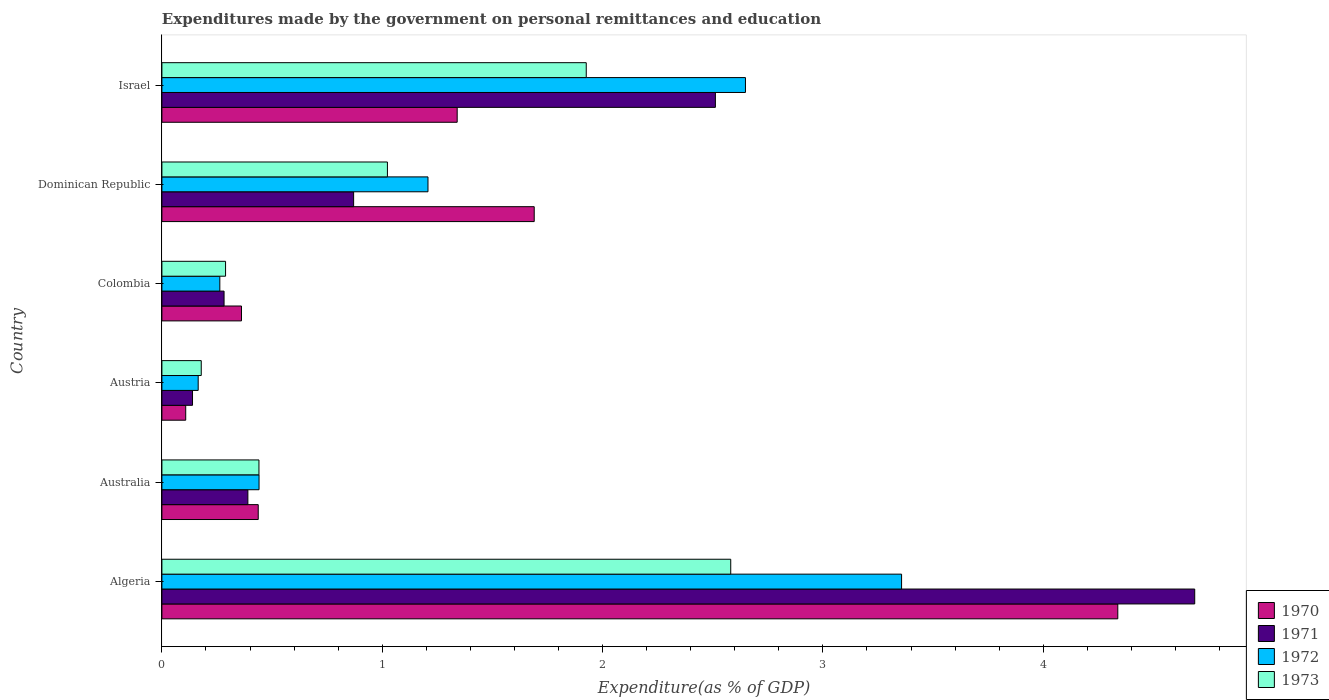How many groups of bars are there?
Offer a very short reply. 6. Are the number of bars per tick equal to the number of legend labels?
Your answer should be compact. Yes. Are the number of bars on each tick of the Y-axis equal?
Provide a succinct answer. Yes. In how many cases, is the number of bars for a given country not equal to the number of legend labels?
Offer a very short reply. 0. What is the expenditures made by the government on personal remittances and education in 1972 in Colombia?
Your answer should be compact. 0.26. Across all countries, what is the maximum expenditures made by the government on personal remittances and education in 1973?
Provide a succinct answer. 2.58. Across all countries, what is the minimum expenditures made by the government on personal remittances and education in 1972?
Provide a succinct answer. 0.16. In which country was the expenditures made by the government on personal remittances and education in 1973 maximum?
Offer a very short reply. Algeria. What is the total expenditures made by the government on personal remittances and education in 1971 in the graph?
Ensure brevity in your answer.  8.88. What is the difference between the expenditures made by the government on personal remittances and education in 1970 in Austria and that in Israel?
Your answer should be very brief. -1.23. What is the difference between the expenditures made by the government on personal remittances and education in 1972 in Australia and the expenditures made by the government on personal remittances and education in 1971 in Algeria?
Offer a very short reply. -4.25. What is the average expenditures made by the government on personal remittances and education in 1971 per country?
Keep it short and to the point. 1.48. What is the difference between the expenditures made by the government on personal remittances and education in 1971 and expenditures made by the government on personal remittances and education in 1970 in Israel?
Your answer should be very brief. 1.17. What is the ratio of the expenditures made by the government on personal remittances and education in 1973 in Algeria to that in Colombia?
Provide a short and direct response. 8.94. Is the difference between the expenditures made by the government on personal remittances and education in 1971 in Algeria and Austria greater than the difference between the expenditures made by the government on personal remittances and education in 1970 in Algeria and Austria?
Your answer should be very brief. Yes. What is the difference between the highest and the second highest expenditures made by the government on personal remittances and education in 1971?
Provide a short and direct response. 2.18. What is the difference between the highest and the lowest expenditures made by the government on personal remittances and education in 1970?
Give a very brief answer. 4.23. In how many countries, is the expenditures made by the government on personal remittances and education in 1972 greater than the average expenditures made by the government on personal remittances and education in 1972 taken over all countries?
Offer a terse response. 2. Is the sum of the expenditures made by the government on personal remittances and education in 1973 in Algeria and Austria greater than the maximum expenditures made by the government on personal remittances and education in 1970 across all countries?
Your response must be concise. No. Is it the case that in every country, the sum of the expenditures made by the government on personal remittances and education in 1972 and expenditures made by the government on personal remittances and education in 1970 is greater than the sum of expenditures made by the government on personal remittances and education in 1971 and expenditures made by the government on personal remittances and education in 1973?
Provide a succinct answer. No. What does the 4th bar from the bottom in Austria represents?
Your answer should be compact. 1973. Is it the case that in every country, the sum of the expenditures made by the government on personal remittances and education in 1971 and expenditures made by the government on personal remittances and education in 1972 is greater than the expenditures made by the government on personal remittances and education in 1973?
Provide a succinct answer. Yes. How many bars are there?
Offer a very short reply. 24. Are all the bars in the graph horizontal?
Ensure brevity in your answer.  Yes. How many countries are there in the graph?
Provide a short and direct response. 6. What is the difference between two consecutive major ticks on the X-axis?
Your answer should be very brief. 1. Does the graph contain any zero values?
Provide a succinct answer. No. Does the graph contain grids?
Give a very brief answer. No. Where does the legend appear in the graph?
Keep it short and to the point. Bottom right. How are the legend labels stacked?
Ensure brevity in your answer.  Vertical. What is the title of the graph?
Ensure brevity in your answer.  Expenditures made by the government on personal remittances and education. Does "1983" appear as one of the legend labels in the graph?
Provide a succinct answer. No. What is the label or title of the X-axis?
Keep it short and to the point. Expenditure(as % of GDP). What is the label or title of the Y-axis?
Your answer should be very brief. Country. What is the Expenditure(as % of GDP) in 1970 in Algeria?
Your response must be concise. 4.34. What is the Expenditure(as % of GDP) in 1971 in Algeria?
Your answer should be very brief. 4.69. What is the Expenditure(as % of GDP) in 1972 in Algeria?
Ensure brevity in your answer.  3.36. What is the Expenditure(as % of GDP) in 1973 in Algeria?
Offer a terse response. 2.58. What is the Expenditure(as % of GDP) in 1970 in Australia?
Provide a short and direct response. 0.44. What is the Expenditure(as % of GDP) in 1971 in Australia?
Keep it short and to the point. 0.39. What is the Expenditure(as % of GDP) of 1972 in Australia?
Your answer should be very brief. 0.44. What is the Expenditure(as % of GDP) of 1973 in Australia?
Provide a succinct answer. 0.44. What is the Expenditure(as % of GDP) of 1970 in Austria?
Give a very brief answer. 0.11. What is the Expenditure(as % of GDP) of 1971 in Austria?
Your answer should be very brief. 0.14. What is the Expenditure(as % of GDP) of 1972 in Austria?
Your response must be concise. 0.16. What is the Expenditure(as % of GDP) in 1973 in Austria?
Your response must be concise. 0.18. What is the Expenditure(as % of GDP) in 1970 in Colombia?
Provide a succinct answer. 0.36. What is the Expenditure(as % of GDP) of 1971 in Colombia?
Keep it short and to the point. 0.28. What is the Expenditure(as % of GDP) in 1972 in Colombia?
Provide a succinct answer. 0.26. What is the Expenditure(as % of GDP) of 1973 in Colombia?
Your answer should be compact. 0.29. What is the Expenditure(as % of GDP) of 1970 in Dominican Republic?
Provide a succinct answer. 1.69. What is the Expenditure(as % of GDP) of 1971 in Dominican Republic?
Your response must be concise. 0.87. What is the Expenditure(as % of GDP) in 1972 in Dominican Republic?
Ensure brevity in your answer.  1.21. What is the Expenditure(as % of GDP) in 1973 in Dominican Republic?
Provide a short and direct response. 1.02. What is the Expenditure(as % of GDP) of 1970 in Israel?
Keep it short and to the point. 1.34. What is the Expenditure(as % of GDP) of 1971 in Israel?
Ensure brevity in your answer.  2.51. What is the Expenditure(as % of GDP) of 1972 in Israel?
Provide a succinct answer. 2.65. What is the Expenditure(as % of GDP) in 1973 in Israel?
Offer a terse response. 1.93. Across all countries, what is the maximum Expenditure(as % of GDP) of 1970?
Give a very brief answer. 4.34. Across all countries, what is the maximum Expenditure(as % of GDP) of 1971?
Your answer should be compact. 4.69. Across all countries, what is the maximum Expenditure(as % of GDP) in 1972?
Provide a short and direct response. 3.36. Across all countries, what is the maximum Expenditure(as % of GDP) of 1973?
Your response must be concise. 2.58. Across all countries, what is the minimum Expenditure(as % of GDP) of 1970?
Your answer should be very brief. 0.11. Across all countries, what is the minimum Expenditure(as % of GDP) of 1971?
Make the answer very short. 0.14. Across all countries, what is the minimum Expenditure(as % of GDP) of 1972?
Give a very brief answer. 0.16. Across all countries, what is the minimum Expenditure(as % of GDP) of 1973?
Offer a terse response. 0.18. What is the total Expenditure(as % of GDP) of 1970 in the graph?
Provide a succinct answer. 8.27. What is the total Expenditure(as % of GDP) in 1971 in the graph?
Provide a succinct answer. 8.88. What is the total Expenditure(as % of GDP) in 1972 in the graph?
Offer a terse response. 8.08. What is the total Expenditure(as % of GDP) of 1973 in the graph?
Provide a short and direct response. 6.44. What is the difference between the Expenditure(as % of GDP) of 1970 in Algeria and that in Australia?
Your answer should be very brief. 3.9. What is the difference between the Expenditure(as % of GDP) in 1971 in Algeria and that in Australia?
Your answer should be compact. 4.3. What is the difference between the Expenditure(as % of GDP) in 1972 in Algeria and that in Australia?
Give a very brief answer. 2.92. What is the difference between the Expenditure(as % of GDP) in 1973 in Algeria and that in Australia?
Offer a very short reply. 2.14. What is the difference between the Expenditure(as % of GDP) of 1970 in Algeria and that in Austria?
Your answer should be very brief. 4.23. What is the difference between the Expenditure(as % of GDP) of 1971 in Algeria and that in Austria?
Ensure brevity in your answer.  4.55. What is the difference between the Expenditure(as % of GDP) of 1972 in Algeria and that in Austria?
Your answer should be compact. 3.19. What is the difference between the Expenditure(as % of GDP) in 1973 in Algeria and that in Austria?
Your response must be concise. 2.4. What is the difference between the Expenditure(as % of GDP) in 1970 in Algeria and that in Colombia?
Give a very brief answer. 3.98. What is the difference between the Expenditure(as % of GDP) in 1971 in Algeria and that in Colombia?
Offer a terse response. 4.41. What is the difference between the Expenditure(as % of GDP) in 1972 in Algeria and that in Colombia?
Make the answer very short. 3.09. What is the difference between the Expenditure(as % of GDP) in 1973 in Algeria and that in Colombia?
Your response must be concise. 2.29. What is the difference between the Expenditure(as % of GDP) of 1970 in Algeria and that in Dominican Republic?
Provide a short and direct response. 2.65. What is the difference between the Expenditure(as % of GDP) of 1971 in Algeria and that in Dominican Republic?
Make the answer very short. 3.82. What is the difference between the Expenditure(as % of GDP) of 1972 in Algeria and that in Dominican Republic?
Make the answer very short. 2.15. What is the difference between the Expenditure(as % of GDP) in 1973 in Algeria and that in Dominican Republic?
Ensure brevity in your answer.  1.56. What is the difference between the Expenditure(as % of GDP) of 1970 in Algeria and that in Israel?
Keep it short and to the point. 3. What is the difference between the Expenditure(as % of GDP) in 1971 in Algeria and that in Israel?
Offer a very short reply. 2.18. What is the difference between the Expenditure(as % of GDP) in 1972 in Algeria and that in Israel?
Your response must be concise. 0.71. What is the difference between the Expenditure(as % of GDP) in 1973 in Algeria and that in Israel?
Offer a terse response. 0.66. What is the difference between the Expenditure(as % of GDP) of 1970 in Australia and that in Austria?
Provide a succinct answer. 0.33. What is the difference between the Expenditure(as % of GDP) in 1971 in Australia and that in Austria?
Provide a succinct answer. 0.25. What is the difference between the Expenditure(as % of GDP) in 1972 in Australia and that in Austria?
Your answer should be compact. 0.28. What is the difference between the Expenditure(as % of GDP) of 1973 in Australia and that in Austria?
Ensure brevity in your answer.  0.26. What is the difference between the Expenditure(as % of GDP) of 1970 in Australia and that in Colombia?
Provide a succinct answer. 0.08. What is the difference between the Expenditure(as % of GDP) in 1971 in Australia and that in Colombia?
Give a very brief answer. 0.11. What is the difference between the Expenditure(as % of GDP) in 1972 in Australia and that in Colombia?
Keep it short and to the point. 0.18. What is the difference between the Expenditure(as % of GDP) in 1973 in Australia and that in Colombia?
Your answer should be compact. 0.15. What is the difference between the Expenditure(as % of GDP) in 1970 in Australia and that in Dominican Republic?
Provide a short and direct response. -1.25. What is the difference between the Expenditure(as % of GDP) in 1971 in Australia and that in Dominican Republic?
Give a very brief answer. -0.48. What is the difference between the Expenditure(as % of GDP) in 1972 in Australia and that in Dominican Republic?
Offer a terse response. -0.77. What is the difference between the Expenditure(as % of GDP) in 1973 in Australia and that in Dominican Republic?
Offer a very short reply. -0.58. What is the difference between the Expenditure(as % of GDP) of 1970 in Australia and that in Israel?
Give a very brief answer. -0.9. What is the difference between the Expenditure(as % of GDP) of 1971 in Australia and that in Israel?
Offer a very short reply. -2.12. What is the difference between the Expenditure(as % of GDP) in 1972 in Australia and that in Israel?
Make the answer very short. -2.21. What is the difference between the Expenditure(as % of GDP) of 1973 in Australia and that in Israel?
Keep it short and to the point. -1.49. What is the difference between the Expenditure(as % of GDP) in 1970 in Austria and that in Colombia?
Provide a short and direct response. -0.25. What is the difference between the Expenditure(as % of GDP) in 1971 in Austria and that in Colombia?
Your response must be concise. -0.14. What is the difference between the Expenditure(as % of GDP) in 1972 in Austria and that in Colombia?
Your response must be concise. -0.1. What is the difference between the Expenditure(as % of GDP) in 1973 in Austria and that in Colombia?
Give a very brief answer. -0.11. What is the difference between the Expenditure(as % of GDP) of 1970 in Austria and that in Dominican Republic?
Give a very brief answer. -1.58. What is the difference between the Expenditure(as % of GDP) of 1971 in Austria and that in Dominican Republic?
Offer a very short reply. -0.73. What is the difference between the Expenditure(as % of GDP) in 1972 in Austria and that in Dominican Republic?
Keep it short and to the point. -1.04. What is the difference between the Expenditure(as % of GDP) of 1973 in Austria and that in Dominican Republic?
Your answer should be compact. -0.84. What is the difference between the Expenditure(as % of GDP) of 1970 in Austria and that in Israel?
Give a very brief answer. -1.23. What is the difference between the Expenditure(as % of GDP) in 1971 in Austria and that in Israel?
Your answer should be very brief. -2.37. What is the difference between the Expenditure(as % of GDP) in 1972 in Austria and that in Israel?
Offer a very short reply. -2.48. What is the difference between the Expenditure(as % of GDP) of 1973 in Austria and that in Israel?
Offer a very short reply. -1.75. What is the difference between the Expenditure(as % of GDP) in 1970 in Colombia and that in Dominican Republic?
Your response must be concise. -1.33. What is the difference between the Expenditure(as % of GDP) of 1971 in Colombia and that in Dominican Republic?
Your answer should be very brief. -0.59. What is the difference between the Expenditure(as % of GDP) in 1972 in Colombia and that in Dominican Republic?
Your answer should be compact. -0.94. What is the difference between the Expenditure(as % of GDP) in 1973 in Colombia and that in Dominican Republic?
Your answer should be very brief. -0.73. What is the difference between the Expenditure(as % of GDP) of 1970 in Colombia and that in Israel?
Keep it short and to the point. -0.98. What is the difference between the Expenditure(as % of GDP) of 1971 in Colombia and that in Israel?
Your answer should be very brief. -2.23. What is the difference between the Expenditure(as % of GDP) of 1972 in Colombia and that in Israel?
Give a very brief answer. -2.39. What is the difference between the Expenditure(as % of GDP) of 1973 in Colombia and that in Israel?
Your response must be concise. -1.64. What is the difference between the Expenditure(as % of GDP) of 1970 in Dominican Republic and that in Israel?
Your response must be concise. 0.35. What is the difference between the Expenditure(as % of GDP) of 1971 in Dominican Republic and that in Israel?
Provide a short and direct response. -1.64. What is the difference between the Expenditure(as % of GDP) of 1972 in Dominican Republic and that in Israel?
Make the answer very short. -1.44. What is the difference between the Expenditure(as % of GDP) in 1973 in Dominican Republic and that in Israel?
Offer a terse response. -0.9. What is the difference between the Expenditure(as % of GDP) of 1970 in Algeria and the Expenditure(as % of GDP) of 1971 in Australia?
Ensure brevity in your answer.  3.95. What is the difference between the Expenditure(as % of GDP) of 1970 in Algeria and the Expenditure(as % of GDP) of 1972 in Australia?
Ensure brevity in your answer.  3.9. What is the difference between the Expenditure(as % of GDP) in 1970 in Algeria and the Expenditure(as % of GDP) in 1973 in Australia?
Your answer should be compact. 3.9. What is the difference between the Expenditure(as % of GDP) in 1971 in Algeria and the Expenditure(as % of GDP) in 1972 in Australia?
Your response must be concise. 4.25. What is the difference between the Expenditure(as % of GDP) in 1971 in Algeria and the Expenditure(as % of GDP) in 1973 in Australia?
Provide a short and direct response. 4.25. What is the difference between the Expenditure(as % of GDP) of 1972 in Algeria and the Expenditure(as % of GDP) of 1973 in Australia?
Give a very brief answer. 2.92. What is the difference between the Expenditure(as % of GDP) in 1970 in Algeria and the Expenditure(as % of GDP) in 1971 in Austria?
Make the answer very short. 4.2. What is the difference between the Expenditure(as % of GDP) of 1970 in Algeria and the Expenditure(as % of GDP) of 1972 in Austria?
Ensure brevity in your answer.  4.17. What is the difference between the Expenditure(as % of GDP) in 1970 in Algeria and the Expenditure(as % of GDP) in 1973 in Austria?
Your answer should be very brief. 4.16. What is the difference between the Expenditure(as % of GDP) in 1971 in Algeria and the Expenditure(as % of GDP) in 1972 in Austria?
Ensure brevity in your answer.  4.52. What is the difference between the Expenditure(as % of GDP) in 1971 in Algeria and the Expenditure(as % of GDP) in 1973 in Austria?
Offer a terse response. 4.51. What is the difference between the Expenditure(as % of GDP) in 1972 in Algeria and the Expenditure(as % of GDP) in 1973 in Austria?
Offer a terse response. 3.18. What is the difference between the Expenditure(as % of GDP) of 1970 in Algeria and the Expenditure(as % of GDP) of 1971 in Colombia?
Your response must be concise. 4.06. What is the difference between the Expenditure(as % of GDP) in 1970 in Algeria and the Expenditure(as % of GDP) in 1972 in Colombia?
Your response must be concise. 4.08. What is the difference between the Expenditure(as % of GDP) of 1970 in Algeria and the Expenditure(as % of GDP) of 1973 in Colombia?
Provide a succinct answer. 4.05. What is the difference between the Expenditure(as % of GDP) of 1971 in Algeria and the Expenditure(as % of GDP) of 1972 in Colombia?
Provide a short and direct response. 4.42. What is the difference between the Expenditure(as % of GDP) in 1971 in Algeria and the Expenditure(as % of GDP) in 1973 in Colombia?
Provide a short and direct response. 4.4. What is the difference between the Expenditure(as % of GDP) in 1972 in Algeria and the Expenditure(as % of GDP) in 1973 in Colombia?
Your response must be concise. 3.07. What is the difference between the Expenditure(as % of GDP) in 1970 in Algeria and the Expenditure(as % of GDP) in 1971 in Dominican Republic?
Provide a succinct answer. 3.47. What is the difference between the Expenditure(as % of GDP) in 1970 in Algeria and the Expenditure(as % of GDP) in 1972 in Dominican Republic?
Provide a short and direct response. 3.13. What is the difference between the Expenditure(as % of GDP) of 1970 in Algeria and the Expenditure(as % of GDP) of 1973 in Dominican Republic?
Provide a short and direct response. 3.31. What is the difference between the Expenditure(as % of GDP) of 1971 in Algeria and the Expenditure(as % of GDP) of 1972 in Dominican Republic?
Provide a short and direct response. 3.48. What is the difference between the Expenditure(as % of GDP) of 1971 in Algeria and the Expenditure(as % of GDP) of 1973 in Dominican Republic?
Offer a very short reply. 3.66. What is the difference between the Expenditure(as % of GDP) of 1972 in Algeria and the Expenditure(as % of GDP) of 1973 in Dominican Republic?
Provide a succinct answer. 2.33. What is the difference between the Expenditure(as % of GDP) of 1970 in Algeria and the Expenditure(as % of GDP) of 1971 in Israel?
Ensure brevity in your answer.  1.83. What is the difference between the Expenditure(as % of GDP) in 1970 in Algeria and the Expenditure(as % of GDP) in 1972 in Israel?
Make the answer very short. 1.69. What is the difference between the Expenditure(as % of GDP) of 1970 in Algeria and the Expenditure(as % of GDP) of 1973 in Israel?
Keep it short and to the point. 2.41. What is the difference between the Expenditure(as % of GDP) of 1971 in Algeria and the Expenditure(as % of GDP) of 1972 in Israel?
Your answer should be compact. 2.04. What is the difference between the Expenditure(as % of GDP) in 1971 in Algeria and the Expenditure(as % of GDP) in 1973 in Israel?
Provide a short and direct response. 2.76. What is the difference between the Expenditure(as % of GDP) of 1972 in Algeria and the Expenditure(as % of GDP) of 1973 in Israel?
Ensure brevity in your answer.  1.43. What is the difference between the Expenditure(as % of GDP) in 1970 in Australia and the Expenditure(as % of GDP) in 1971 in Austria?
Offer a very short reply. 0.3. What is the difference between the Expenditure(as % of GDP) of 1970 in Australia and the Expenditure(as % of GDP) of 1972 in Austria?
Make the answer very short. 0.27. What is the difference between the Expenditure(as % of GDP) of 1970 in Australia and the Expenditure(as % of GDP) of 1973 in Austria?
Offer a terse response. 0.26. What is the difference between the Expenditure(as % of GDP) in 1971 in Australia and the Expenditure(as % of GDP) in 1972 in Austria?
Make the answer very short. 0.23. What is the difference between the Expenditure(as % of GDP) of 1971 in Australia and the Expenditure(as % of GDP) of 1973 in Austria?
Offer a terse response. 0.21. What is the difference between the Expenditure(as % of GDP) in 1972 in Australia and the Expenditure(as % of GDP) in 1973 in Austria?
Provide a succinct answer. 0.26. What is the difference between the Expenditure(as % of GDP) in 1970 in Australia and the Expenditure(as % of GDP) in 1971 in Colombia?
Offer a very short reply. 0.15. What is the difference between the Expenditure(as % of GDP) in 1970 in Australia and the Expenditure(as % of GDP) in 1972 in Colombia?
Offer a very short reply. 0.17. What is the difference between the Expenditure(as % of GDP) in 1970 in Australia and the Expenditure(as % of GDP) in 1973 in Colombia?
Offer a very short reply. 0.15. What is the difference between the Expenditure(as % of GDP) of 1971 in Australia and the Expenditure(as % of GDP) of 1972 in Colombia?
Give a very brief answer. 0.13. What is the difference between the Expenditure(as % of GDP) of 1971 in Australia and the Expenditure(as % of GDP) of 1973 in Colombia?
Ensure brevity in your answer.  0.1. What is the difference between the Expenditure(as % of GDP) of 1972 in Australia and the Expenditure(as % of GDP) of 1973 in Colombia?
Your answer should be very brief. 0.15. What is the difference between the Expenditure(as % of GDP) of 1970 in Australia and the Expenditure(as % of GDP) of 1971 in Dominican Republic?
Provide a succinct answer. -0.43. What is the difference between the Expenditure(as % of GDP) in 1970 in Australia and the Expenditure(as % of GDP) in 1972 in Dominican Republic?
Offer a terse response. -0.77. What is the difference between the Expenditure(as % of GDP) in 1970 in Australia and the Expenditure(as % of GDP) in 1973 in Dominican Republic?
Offer a very short reply. -0.59. What is the difference between the Expenditure(as % of GDP) of 1971 in Australia and the Expenditure(as % of GDP) of 1972 in Dominican Republic?
Your answer should be compact. -0.82. What is the difference between the Expenditure(as % of GDP) in 1971 in Australia and the Expenditure(as % of GDP) in 1973 in Dominican Republic?
Keep it short and to the point. -0.63. What is the difference between the Expenditure(as % of GDP) in 1972 in Australia and the Expenditure(as % of GDP) in 1973 in Dominican Republic?
Ensure brevity in your answer.  -0.58. What is the difference between the Expenditure(as % of GDP) in 1970 in Australia and the Expenditure(as % of GDP) in 1971 in Israel?
Offer a terse response. -2.07. What is the difference between the Expenditure(as % of GDP) of 1970 in Australia and the Expenditure(as % of GDP) of 1972 in Israel?
Give a very brief answer. -2.21. What is the difference between the Expenditure(as % of GDP) in 1970 in Australia and the Expenditure(as % of GDP) in 1973 in Israel?
Give a very brief answer. -1.49. What is the difference between the Expenditure(as % of GDP) of 1971 in Australia and the Expenditure(as % of GDP) of 1972 in Israel?
Keep it short and to the point. -2.26. What is the difference between the Expenditure(as % of GDP) of 1971 in Australia and the Expenditure(as % of GDP) of 1973 in Israel?
Keep it short and to the point. -1.54. What is the difference between the Expenditure(as % of GDP) of 1972 in Australia and the Expenditure(as % of GDP) of 1973 in Israel?
Your answer should be very brief. -1.49. What is the difference between the Expenditure(as % of GDP) of 1970 in Austria and the Expenditure(as % of GDP) of 1971 in Colombia?
Make the answer very short. -0.17. What is the difference between the Expenditure(as % of GDP) of 1970 in Austria and the Expenditure(as % of GDP) of 1972 in Colombia?
Make the answer very short. -0.15. What is the difference between the Expenditure(as % of GDP) of 1970 in Austria and the Expenditure(as % of GDP) of 1973 in Colombia?
Keep it short and to the point. -0.18. What is the difference between the Expenditure(as % of GDP) in 1971 in Austria and the Expenditure(as % of GDP) in 1972 in Colombia?
Offer a very short reply. -0.12. What is the difference between the Expenditure(as % of GDP) of 1971 in Austria and the Expenditure(as % of GDP) of 1973 in Colombia?
Your answer should be very brief. -0.15. What is the difference between the Expenditure(as % of GDP) in 1972 in Austria and the Expenditure(as % of GDP) in 1973 in Colombia?
Give a very brief answer. -0.12. What is the difference between the Expenditure(as % of GDP) in 1970 in Austria and the Expenditure(as % of GDP) in 1971 in Dominican Republic?
Your response must be concise. -0.76. What is the difference between the Expenditure(as % of GDP) of 1970 in Austria and the Expenditure(as % of GDP) of 1972 in Dominican Republic?
Your response must be concise. -1.1. What is the difference between the Expenditure(as % of GDP) of 1970 in Austria and the Expenditure(as % of GDP) of 1973 in Dominican Republic?
Offer a very short reply. -0.92. What is the difference between the Expenditure(as % of GDP) of 1971 in Austria and the Expenditure(as % of GDP) of 1972 in Dominican Republic?
Give a very brief answer. -1.07. What is the difference between the Expenditure(as % of GDP) in 1971 in Austria and the Expenditure(as % of GDP) in 1973 in Dominican Republic?
Offer a very short reply. -0.88. What is the difference between the Expenditure(as % of GDP) in 1972 in Austria and the Expenditure(as % of GDP) in 1973 in Dominican Republic?
Offer a very short reply. -0.86. What is the difference between the Expenditure(as % of GDP) of 1970 in Austria and the Expenditure(as % of GDP) of 1971 in Israel?
Offer a very short reply. -2.4. What is the difference between the Expenditure(as % of GDP) in 1970 in Austria and the Expenditure(as % of GDP) in 1972 in Israel?
Your response must be concise. -2.54. What is the difference between the Expenditure(as % of GDP) of 1970 in Austria and the Expenditure(as % of GDP) of 1973 in Israel?
Keep it short and to the point. -1.82. What is the difference between the Expenditure(as % of GDP) in 1971 in Austria and the Expenditure(as % of GDP) in 1972 in Israel?
Make the answer very short. -2.51. What is the difference between the Expenditure(as % of GDP) of 1971 in Austria and the Expenditure(as % of GDP) of 1973 in Israel?
Provide a succinct answer. -1.79. What is the difference between the Expenditure(as % of GDP) in 1972 in Austria and the Expenditure(as % of GDP) in 1973 in Israel?
Provide a succinct answer. -1.76. What is the difference between the Expenditure(as % of GDP) of 1970 in Colombia and the Expenditure(as % of GDP) of 1971 in Dominican Republic?
Ensure brevity in your answer.  -0.51. What is the difference between the Expenditure(as % of GDP) in 1970 in Colombia and the Expenditure(as % of GDP) in 1972 in Dominican Republic?
Make the answer very short. -0.85. What is the difference between the Expenditure(as % of GDP) in 1970 in Colombia and the Expenditure(as % of GDP) in 1973 in Dominican Republic?
Your response must be concise. -0.66. What is the difference between the Expenditure(as % of GDP) in 1971 in Colombia and the Expenditure(as % of GDP) in 1972 in Dominican Republic?
Provide a succinct answer. -0.93. What is the difference between the Expenditure(as % of GDP) of 1971 in Colombia and the Expenditure(as % of GDP) of 1973 in Dominican Republic?
Your response must be concise. -0.74. What is the difference between the Expenditure(as % of GDP) of 1972 in Colombia and the Expenditure(as % of GDP) of 1973 in Dominican Republic?
Provide a short and direct response. -0.76. What is the difference between the Expenditure(as % of GDP) in 1970 in Colombia and the Expenditure(as % of GDP) in 1971 in Israel?
Provide a succinct answer. -2.15. What is the difference between the Expenditure(as % of GDP) of 1970 in Colombia and the Expenditure(as % of GDP) of 1972 in Israel?
Give a very brief answer. -2.29. What is the difference between the Expenditure(as % of GDP) of 1970 in Colombia and the Expenditure(as % of GDP) of 1973 in Israel?
Provide a succinct answer. -1.56. What is the difference between the Expenditure(as % of GDP) in 1971 in Colombia and the Expenditure(as % of GDP) in 1972 in Israel?
Make the answer very short. -2.37. What is the difference between the Expenditure(as % of GDP) in 1971 in Colombia and the Expenditure(as % of GDP) in 1973 in Israel?
Your answer should be compact. -1.64. What is the difference between the Expenditure(as % of GDP) of 1972 in Colombia and the Expenditure(as % of GDP) of 1973 in Israel?
Provide a succinct answer. -1.66. What is the difference between the Expenditure(as % of GDP) in 1970 in Dominican Republic and the Expenditure(as % of GDP) in 1971 in Israel?
Offer a very short reply. -0.82. What is the difference between the Expenditure(as % of GDP) in 1970 in Dominican Republic and the Expenditure(as % of GDP) in 1972 in Israel?
Provide a succinct answer. -0.96. What is the difference between the Expenditure(as % of GDP) in 1970 in Dominican Republic and the Expenditure(as % of GDP) in 1973 in Israel?
Provide a short and direct response. -0.24. What is the difference between the Expenditure(as % of GDP) in 1971 in Dominican Republic and the Expenditure(as % of GDP) in 1972 in Israel?
Your answer should be compact. -1.78. What is the difference between the Expenditure(as % of GDP) in 1971 in Dominican Republic and the Expenditure(as % of GDP) in 1973 in Israel?
Offer a terse response. -1.06. What is the difference between the Expenditure(as % of GDP) in 1972 in Dominican Republic and the Expenditure(as % of GDP) in 1973 in Israel?
Provide a short and direct response. -0.72. What is the average Expenditure(as % of GDP) in 1970 per country?
Offer a very short reply. 1.38. What is the average Expenditure(as % of GDP) of 1971 per country?
Your answer should be very brief. 1.48. What is the average Expenditure(as % of GDP) of 1972 per country?
Offer a very short reply. 1.35. What is the average Expenditure(as % of GDP) of 1973 per country?
Ensure brevity in your answer.  1.07. What is the difference between the Expenditure(as % of GDP) of 1970 and Expenditure(as % of GDP) of 1971 in Algeria?
Make the answer very short. -0.35. What is the difference between the Expenditure(as % of GDP) of 1970 and Expenditure(as % of GDP) of 1972 in Algeria?
Provide a short and direct response. 0.98. What is the difference between the Expenditure(as % of GDP) in 1970 and Expenditure(as % of GDP) in 1973 in Algeria?
Keep it short and to the point. 1.76. What is the difference between the Expenditure(as % of GDP) of 1971 and Expenditure(as % of GDP) of 1972 in Algeria?
Keep it short and to the point. 1.33. What is the difference between the Expenditure(as % of GDP) in 1971 and Expenditure(as % of GDP) in 1973 in Algeria?
Your response must be concise. 2.11. What is the difference between the Expenditure(as % of GDP) of 1972 and Expenditure(as % of GDP) of 1973 in Algeria?
Make the answer very short. 0.78. What is the difference between the Expenditure(as % of GDP) in 1970 and Expenditure(as % of GDP) in 1971 in Australia?
Provide a short and direct response. 0.05. What is the difference between the Expenditure(as % of GDP) of 1970 and Expenditure(as % of GDP) of 1972 in Australia?
Offer a terse response. -0. What is the difference between the Expenditure(as % of GDP) of 1970 and Expenditure(as % of GDP) of 1973 in Australia?
Offer a terse response. -0. What is the difference between the Expenditure(as % of GDP) in 1971 and Expenditure(as % of GDP) in 1972 in Australia?
Ensure brevity in your answer.  -0.05. What is the difference between the Expenditure(as % of GDP) in 1971 and Expenditure(as % of GDP) in 1973 in Australia?
Offer a very short reply. -0.05. What is the difference between the Expenditure(as % of GDP) of 1972 and Expenditure(as % of GDP) of 1973 in Australia?
Your response must be concise. 0. What is the difference between the Expenditure(as % of GDP) of 1970 and Expenditure(as % of GDP) of 1971 in Austria?
Your answer should be very brief. -0.03. What is the difference between the Expenditure(as % of GDP) of 1970 and Expenditure(as % of GDP) of 1972 in Austria?
Keep it short and to the point. -0.06. What is the difference between the Expenditure(as % of GDP) of 1970 and Expenditure(as % of GDP) of 1973 in Austria?
Make the answer very short. -0.07. What is the difference between the Expenditure(as % of GDP) of 1971 and Expenditure(as % of GDP) of 1972 in Austria?
Keep it short and to the point. -0.03. What is the difference between the Expenditure(as % of GDP) of 1971 and Expenditure(as % of GDP) of 1973 in Austria?
Provide a succinct answer. -0.04. What is the difference between the Expenditure(as % of GDP) of 1972 and Expenditure(as % of GDP) of 1973 in Austria?
Offer a very short reply. -0.01. What is the difference between the Expenditure(as % of GDP) in 1970 and Expenditure(as % of GDP) in 1971 in Colombia?
Your response must be concise. 0.08. What is the difference between the Expenditure(as % of GDP) in 1970 and Expenditure(as % of GDP) in 1972 in Colombia?
Provide a succinct answer. 0.1. What is the difference between the Expenditure(as % of GDP) of 1970 and Expenditure(as % of GDP) of 1973 in Colombia?
Your answer should be very brief. 0.07. What is the difference between the Expenditure(as % of GDP) in 1971 and Expenditure(as % of GDP) in 1972 in Colombia?
Give a very brief answer. 0.02. What is the difference between the Expenditure(as % of GDP) in 1971 and Expenditure(as % of GDP) in 1973 in Colombia?
Your answer should be compact. -0.01. What is the difference between the Expenditure(as % of GDP) in 1972 and Expenditure(as % of GDP) in 1973 in Colombia?
Provide a short and direct response. -0.03. What is the difference between the Expenditure(as % of GDP) in 1970 and Expenditure(as % of GDP) in 1971 in Dominican Republic?
Provide a short and direct response. 0.82. What is the difference between the Expenditure(as % of GDP) in 1970 and Expenditure(as % of GDP) in 1972 in Dominican Republic?
Ensure brevity in your answer.  0.48. What is the difference between the Expenditure(as % of GDP) of 1970 and Expenditure(as % of GDP) of 1973 in Dominican Republic?
Ensure brevity in your answer.  0.67. What is the difference between the Expenditure(as % of GDP) in 1971 and Expenditure(as % of GDP) in 1972 in Dominican Republic?
Make the answer very short. -0.34. What is the difference between the Expenditure(as % of GDP) of 1971 and Expenditure(as % of GDP) of 1973 in Dominican Republic?
Provide a short and direct response. -0.15. What is the difference between the Expenditure(as % of GDP) in 1972 and Expenditure(as % of GDP) in 1973 in Dominican Republic?
Your answer should be compact. 0.18. What is the difference between the Expenditure(as % of GDP) of 1970 and Expenditure(as % of GDP) of 1971 in Israel?
Keep it short and to the point. -1.17. What is the difference between the Expenditure(as % of GDP) in 1970 and Expenditure(as % of GDP) in 1972 in Israel?
Keep it short and to the point. -1.31. What is the difference between the Expenditure(as % of GDP) in 1970 and Expenditure(as % of GDP) in 1973 in Israel?
Your answer should be compact. -0.59. What is the difference between the Expenditure(as % of GDP) in 1971 and Expenditure(as % of GDP) in 1972 in Israel?
Your answer should be very brief. -0.14. What is the difference between the Expenditure(as % of GDP) in 1971 and Expenditure(as % of GDP) in 1973 in Israel?
Your answer should be compact. 0.59. What is the difference between the Expenditure(as % of GDP) in 1972 and Expenditure(as % of GDP) in 1973 in Israel?
Your answer should be very brief. 0.72. What is the ratio of the Expenditure(as % of GDP) of 1970 in Algeria to that in Australia?
Keep it short and to the point. 9.92. What is the ratio of the Expenditure(as % of GDP) of 1971 in Algeria to that in Australia?
Offer a very short reply. 12.01. What is the ratio of the Expenditure(as % of GDP) in 1972 in Algeria to that in Australia?
Ensure brevity in your answer.  7.61. What is the ratio of the Expenditure(as % of GDP) of 1973 in Algeria to that in Australia?
Provide a succinct answer. 5.86. What is the ratio of the Expenditure(as % of GDP) in 1970 in Algeria to that in Austria?
Make the answer very short. 40.14. What is the ratio of the Expenditure(as % of GDP) of 1971 in Algeria to that in Austria?
Offer a terse response. 33.73. What is the ratio of the Expenditure(as % of GDP) of 1972 in Algeria to that in Austria?
Offer a terse response. 20.38. What is the ratio of the Expenditure(as % of GDP) in 1973 in Algeria to that in Austria?
Give a very brief answer. 14.45. What is the ratio of the Expenditure(as % of GDP) of 1970 in Algeria to that in Colombia?
Your answer should be compact. 12.01. What is the ratio of the Expenditure(as % of GDP) in 1971 in Algeria to that in Colombia?
Keep it short and to the point. 16.61. What is the ratio of the Expenditure(as % of GDP) in 1972 in Algeria to that in Colombia?
Provide a short and direct response. 12.77. What is the ratio of the Expenditure(as % of GDP) in 1973 in Algeria to that in Colombia?
Offer a very short reply. 8.94. What is the ratio of the Expenditure(as % of GDP) in 1970 in Algeria to that in Dominican Republic?
Keep it short and to the point. 2.57. What is the ratio of the Expenditure(as % of GDP) in 1971 in Algeria to that in Dominican Republic?
Provide a short and direct response. 5.39. What is the ratio of the Expenditure(as % of GDP) of 1972 in Algeria to that in Dominican Republic?
Your answer should be compact. 2.78. What is the ratio of the Expenditure(as % of GDP) of 1973 in Algeria to that in Dominican Republic?
Your answer should be very brief. 2.52. What is the ratio of the Expenditure(as % of GDP) in 1970 in Algeria to that in Israel?
Offer a terse response. 3.24. What is the ratio of the Expenditure(as % of GDP) in 1971 in Algeria to that in Israel?
Ensure brevity in your answer.  1.87. What is the ratio of the Expenditure(as % of GDP) of 1972 in Algeria to that in Israel?
Keep it short and to the point. 1.27. What is the ratio of the Expenditure(as % of GDP) of 1973 in Algeria to that in Israel?
Your response must be concise. 1.34. What is the ratio of the Expenditure(as % of GDP) in 1970 in Australia to that in Austria?
Provide a short and direct response. 4.04. What is the ratio of the Expenditure(as % of GDP) in 1971 in Australia to that in Austria?
Give a very brief answer. 2.81. What is the ratio of the Expenditure(as % of GDP) of 1972 in Australia to that in Austria?
Provide a succinct answer. 2.68. What is the ratio of the Expenditure(as % of GDP) of 1973 in Australia to that in Austria?
Ensure brevity in your answer.  2.47. What is the ratio of the Expenditure(as % of GDP) in 1970 in Australia to that in Colombia?
Offer a very short reply. 1.21. What is the ratio of the Expenditure(as % of GDP) of 1971 in Australia to that in Colombia?
Your answer should be compact. 1.38. What is the ratio of the Expenditure(as % of GDP) in 1972 in Australia to that in Colombia?
Your response must be concise. 1.68. What is the ratio of the Expenditure(as % of GDP) in 1973 in Australia to that in Colombia?
Your response must be concise. 1.52. What is the ratio of the Expenditure(as % of GDP) in 1970 in Australia to that in Dominican Republic?
Your answer should be very brief. 0.26. What is the ratio of the Expenditure(as % of GDP) of 1971 in Australia to that in Dominican Republic?
Your answer should be compact. 0.45. What is the ratio of the Expenditure(as % of GDP) in 1972 in Australia to that in Dominican Republic?
Give a very brief answer. 0.37. What is the ratio of the Expenditure(as % of GDP) of 1973 in Australia to that in Dominican Republic?
Keep it short and to the point. 0.43. What is the ratio of the Expenditure(as % of GDP) of 1970 in Australia to that in Israel?
Give a very brief answer. 0.33. What is the ratio of the Expenditure(as % of GDP) of 1971 in Australia to that in Israel?
Make the answer very short. 0.16. What is the ratio of the Expenditure(as % of GDP) in 1972 in Australia to that in Israel?
Offer a very short reply. 0.17. What is the ratio of the Expenditure(as % of GDP) in 1973 in Australia to that in Israel?
Offer a very short reply. 0.23. What is the ratio of the Expenditure(as % of GDP) in 1970 in Austria to that in Colombia?
Provide a short and direct response. 0.3. What is the ratio of the Expenditure(as % of GDP) of 1971 in Austria to that in Colombia?
Give a very brief answer. 0.49. What is the ratio of the Expenditure(as % of GDP) of 1972 in Austria to that in Colombia?
Offer a terse response. 0.63. What is the ratio of the Expenditure(as % of GDP) in 1973 in Austria to that in Colombia?
Your response must be concise. 0.62. What is the ratio of the Expenditure(as % of GDP) of 1970 in Austria to that in Dominican Republic?
Your response must be concise. 0.06. What is the ratio of the Expenditure(as % of GDP) in 1971 in Austria to that in Dominican Republic?
Provide a succinct answer. 0.16. What is the ratio of the Expenditure(as % of GDP) of 1972 in Austria to that in Dominican Republic?
Provide a short and direct response. 0.14. What is the ratio of the Expenditure(as % of GDP) in 1973 in Austria to that in Dominican Republic?
Keep it short and to the point. 0.17. What is the ratio of the Expenditure(as % of GDP) in 1970 in Austria to that in Israel?
Your response must be concise. 0.08. What is the ratio of the Expenditure(as % of GDP) in 1971 in Austria to that in Israel?
Ensure brevity in your answer.  0.06. What is the ratio of the Expenditure(as % of GDP) in 1972 in Austria to that in Israel?
Your answer should be very brief. 0.06. What is the ratio of the Expenditure(as % of GDP) in 1973 in Austria to that in Israel?
Keep it short and to the point. 0.09. What is the ratio of the Expenditure(as % of GDP) of 1970 in Colombia to that in Dominican Republic?
Offer a terse response. 0.21. What is the ratio of the Expenditure(as % of GDP) in 1971 in Colombia to that in Dominican Republic?
Offer a very short reply. 0.32. What is the ratio of the Expenditure(as % of GDP) in 1972 in Colombia to that in Dominican Republic?
Give a very brief answer. 0.22. What is the ratio of the Expenditure(as % of GDP) of 1973 in Colombia to that in Dominican Republic?
Offer a terse response. 0.28. What is the ratio of the Expenditure(as % of GDP) of 1970 in Colombia to that in Israel?
Give a very brief answer. 0.27. What is the ratio of the Expenditure(as % of GDP) in 1971 in Colombia to that in Israel?
Give a very brief answer. 0.11. What is the ratio of the Expenditure(as % of GDP) in 1972 in Colombia to that in Israel?
Provide a short and direct response. 0.1. What is the ratio of the Expenditure(as % of GDP) of 1970 in Dominican Republic to that in Israel?
Ensure brevity in your answer.  1.26. What is the ratio of the Expenditure(as % of GDP) of 1971 in Dominican Republic to that in Israel?
Offer a very short reply. 0.35. What is the ratio of the Expenditure(as % of GDP) of 1972 in Dominican Republic to that in Israel?
Provide a succinct answer. 0.46. What is the ratio of the Expenditure(as % of GDP) in 1973 in Dominican Republic to that in Israel?
Make the answer very short. 0.53. What is the difference between the highest and the second highest Expenditure(as % of GDP) in 1970?
Give a very brief answer. 2.65. What is the difference between the highest and the second highest Expenditure(as % of GDP) of 1971?
Give a very brief answer. 2.18. What is the difference between the highest and the second highest Expenditure(as % of GDP) of 1972?
Ensure brevity in your answer.  0.71. What is the difference between the highest and the second highest Expenditure(as % of GDP) in 1973?
Offer a very short reply. 0.66. What is the difference between the highest and the lowest Expenditure(as % of GDP) of 1970?
Your response must be concise. 4.23. What is the difference between the highest and the lowest Expenditure(as % of GDP) of 1971?
Your response must be concise. 4.55. What is the difference between the highest and the lowest Expenditure(as % of GDP) of 1972?
Offer a terse response. 3.19. What is the difference between the highest and the lowest Expenditure(as % of GDP) of 1973?
Your answer should be compact. 2.4. 